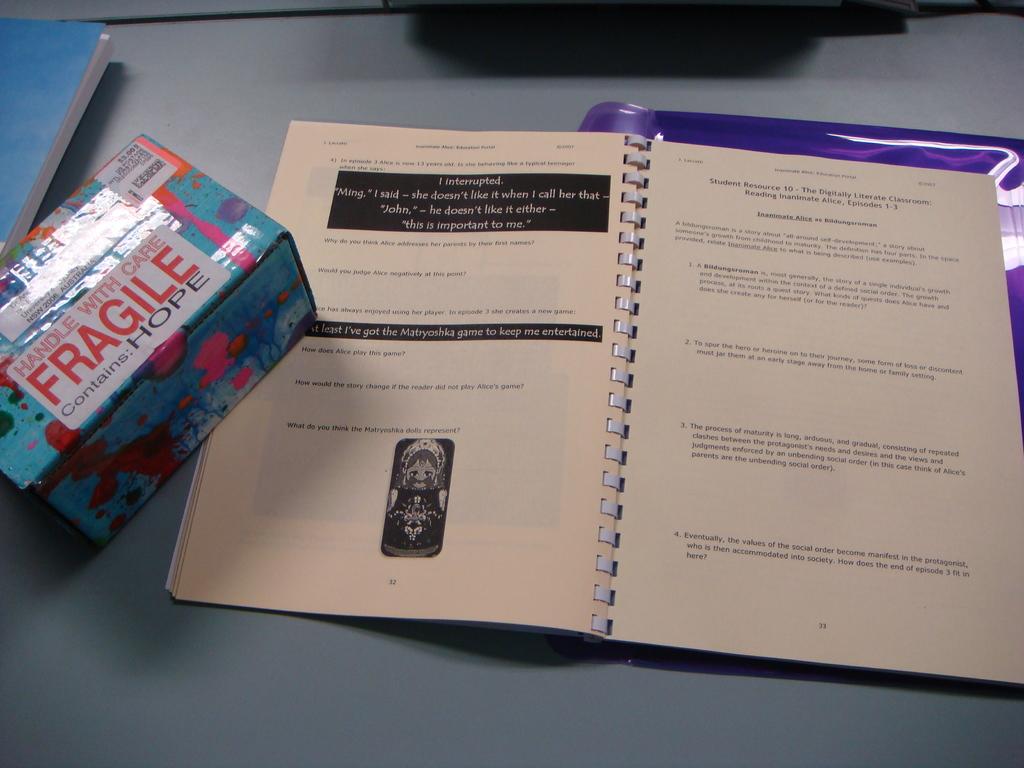What is the word that in red on the book?
Ensure brevity in your answer.  Fragile. How should the box be handled?
Give a very brief answer. With care. 